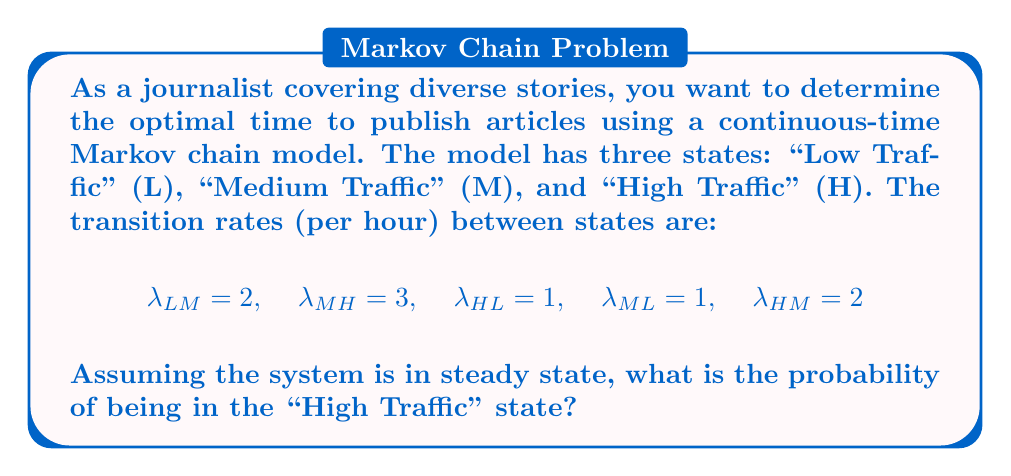Provide a solution to this math problem. To solve this problem, we'll use the following steps:

1) First, we need to set up the transition rate matrix Q:

   $$Q = \begin{bmatrix}
   -2 & 2 & 0 \\
   1 & -4 & 3 \\
   1 & 2 & -3
   \end{bmatrix}$$

2) In steady state, the probabilities satisfy the equation:

   $$\pi Q = 0$$

   where $\pi = [\pi_L, \pi_M, \pi_H]$ is the steady-state probability vector.

3) This gives us the following system of equations:

   $$-2\pi_L + \pi_M + \pi_H = 0$$
   $$2\pi_L - 4\pi_M + 2\pi_H = 0$$
   $$3\pi_M - 3\pi_H = 0$$

4) We also know that the probabilities must sum to 1:

   $$\pi_L + \pi_M + \pi_H = 1$$

5) From the third equation, we can deduce:

   $$\pi_M = \pi_H$$

6) Substituting this into the second equation:

   $$2\pi_L - 4\pi_H + 2\pi_H = 0$$
   $$2\pi_L - 2\pi_H = 0$$
   $$\pi_L = \pi_H$$

7) Now we know that all probabilities are equal. Using the sum-to-one condition:

   $$\pi_L + \pi_M + \pi_H = 1$$
   $$3\pi_H = 1$$
   $$\pi_H = \frac{1}{3}$$

Therefore, the probability of being in the "High Traffic" state is $\frac{1}{3}$.
Answer: $\frac{1}{3}$ 